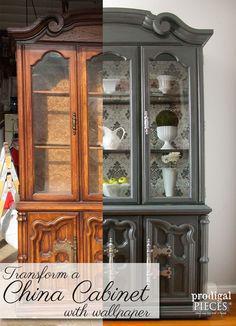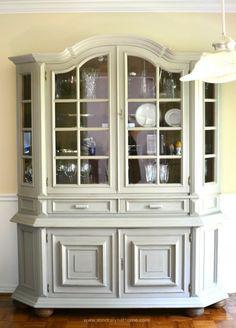The first image is the image on the left, the second image is the image on the right. Given the left and right images, does the statement "There is a chair set up near a white cabinet." hold true? Answer yes or no. No. The first image is the image on the left, the second image is the image on the right. Evaluate the accuracy of this statement regarding the images: "All of the cabinets pictured have flat tops instead of curved tops.". Is it true? Answer yes or no. No. 